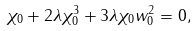<formula> <loc_0><loc_0><loc_500><loc_500>\chi _ { 0 } + 2 \lambda \chi _ { 0 } ^ { 3 } + 3 \lambda \chi _ { 0 } w _ { 0 } ^ { 2 } = 0 ,</formula> 